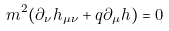Convert formula to latex. <formula><loc_0><loc_0><loc_500><loc_500>m ^ { 2 } ( \partial _ { \nu } h _ { \mu \nu } + q \partial _ { \mu } h ) = 0</formula> 